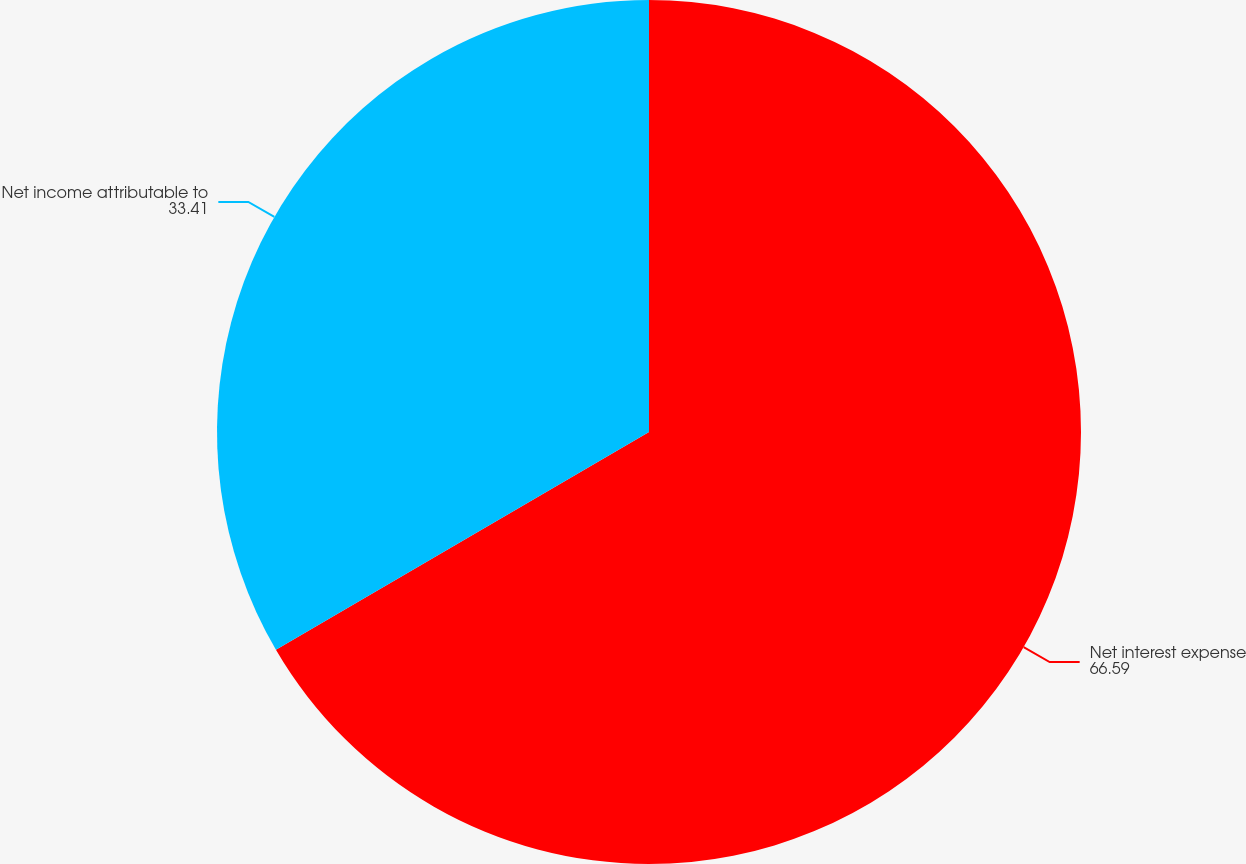Convert chart to OTSL. <chart><loc_0><loc_0><loc_500><loc_500><pie_chart><fcel>Net interest expense<fcel>Net income attributable to<nl><fcel>66.59%<fcel>33.41%<nl></chart> 